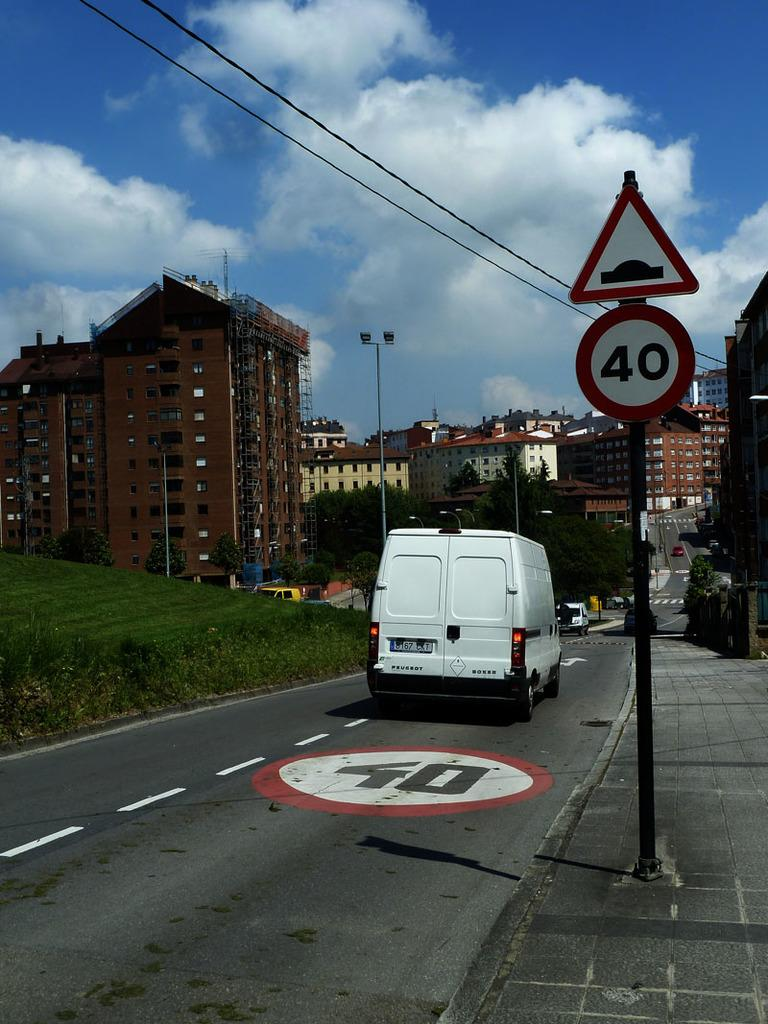<image>
Provide a brief description of the given image. White van in the fourty lane that is headed to the end of the street. 